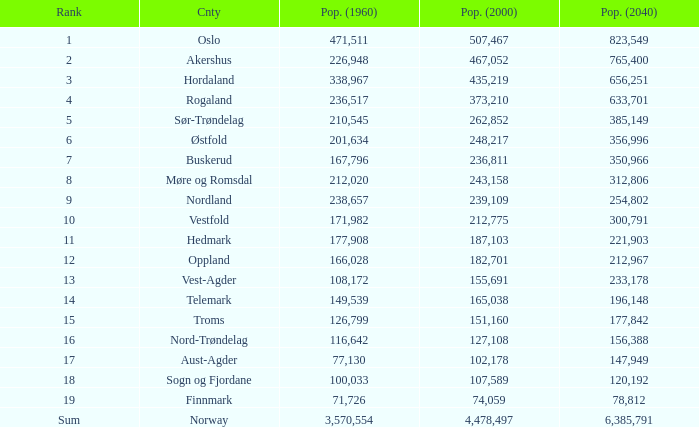What was the demographic size of a county in 2040 that had a population smaller than 108,172 in 2000 and beneath 107,589 in 1960? 2.0. 